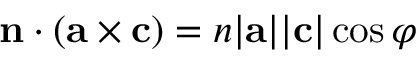Convert formula to latex. <formula><loc_0><loc_0><loc_500><loc_500>n \cdot ( { a } \times { c } ) = n | a | | c | \cos \varphi</formula> 